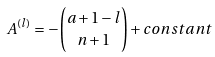<formula> <loc_0><loc_0><loc_500><loc_500>A ^ { ( l ) } = - { a + 1 - l \choose n + 1 } + c o n s t a n t</formula> 